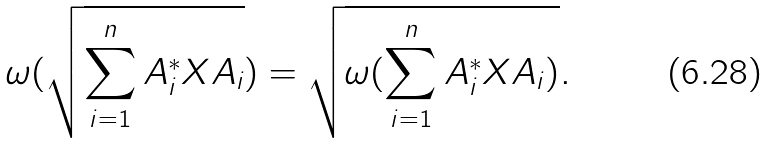<formula> <loc_0><loc_0><loc_500><loc_500>\omega ( { \sqrt { \sum _ { i = 1 } ^ { n } A _ { i } ^ { * } X A _ { i } } } ) = { \sqrt { \omega ( \sum _ { i = 1 } ^ { n } A _ { i } ^ { * } X A _ { i } ) } } .</formula> 